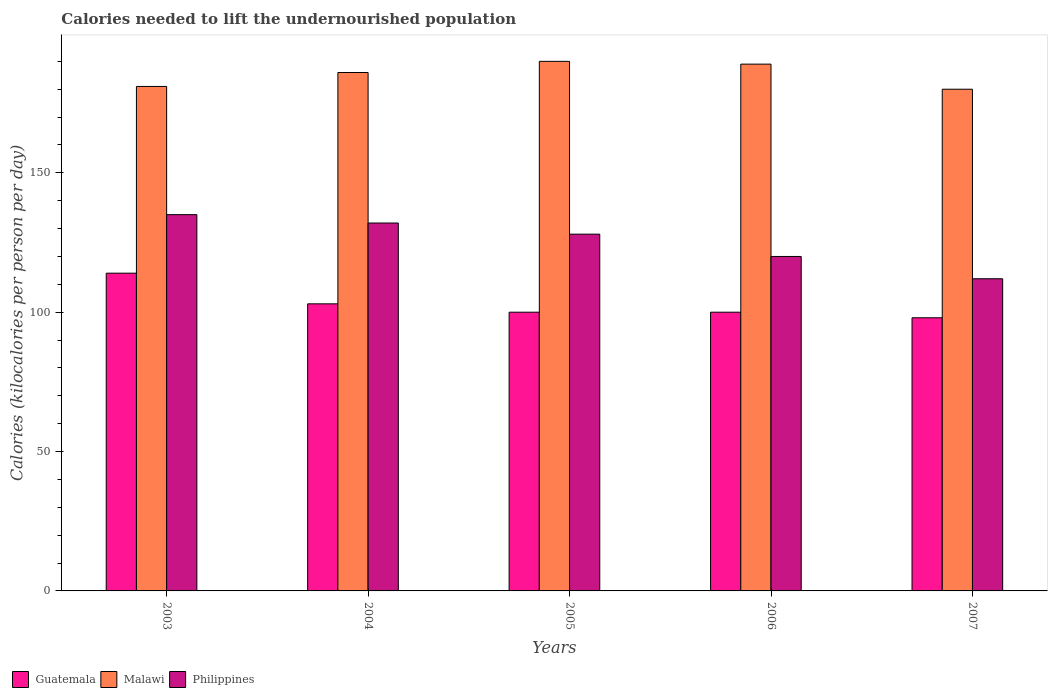How many bars are there on the 3rd tick from the left?
Offer a very short reply. 3. How many bars are there on the 1st tick from the right?
Offer a terse response. 3. What is the total calories needed to lift the undernourished population in Philippines in 2005?
Give a very brief answer. 128. Across all years, what is the maximum total calories needed to lift the undernourished population in Philippines?
Offer a very short reply. 135. Across all years, what is the minimum total calories needed to lift the undernourished population in Malawi?
Ensure brevity in your answer.  180. In which year was the total calories needed to lift the undernourished population in Malawi maximum?
Ensure brevity in your answer.  2005. What is the total total calories needed to lift the undernourished population in Malawi in the graph?
Ensure brevity in your answer.  926. What is the difference between the total calories needed to lift the undernourished population in Malawi in 2004 and that in 2005?
Your answer should be compact. -4. What is the difference between the total calories needed to lift the undernourished population in Malawi in 2003 and the total calories needed to lift the undernourished population in Philippines in 2006?
Keep it short and to the point. 61. What is the average total calories needed to lift the undernourished population in Guatemala per year?
Give a very brief answer. 103. In the year 2007, what is the difference between the total calories needed to lift the undernourished population in Malawi and total calories needed to lift the undernourished population in Guatemala?
Ensure brevity in your answer.  82. In how many years, is the total calories needed to lift the undernourished population in Guatemala greater than 120 kilocalories?
Offer a very short reply. 0. What is the ratio of the total calories needed to lift the undernourished population in Guatemala in 2003 to that in 2004?
Make the answer very short. 1.11. Is the total calories needed to lift the undernourished population in Guatemala in 2004 less than that in 2007?
Provide a succinct answer. No. What is the difference between the highest and the lowest total calories needed to lift the undernourished population in Guatemala?
Your answer should be very brief. 16. In how many years, is the total calories needed to lift the undernourished population in Malawi greater than the average total calories needed to lift the undernourished population in Malawi taken over all years?
Keep it short and to the point. 3. What does the 2nd bar from the left in 2005 represents?
Ensure brevity in your answer.  Malawi. What does the 2nd bar from the right in 2005 represents?
Provide a short and direct response. Malawi. Is it the case that in every year, the sum of the total calories needed to lift the undernourished population in Guatemala and total calories needed to lift the undernourished population in Philippines is greater than the total calories needed to lift the undernourished population in Malawi?
Provide a succinct answer. Yes. Are all the bars in the graph horizontal?
Offer a very short reply. No. How many years are there in the graph?
Your response must be concise. 5. What is the difference between two consecutive major ticks on the Y-axis?
Your answer should be very brief. 50. Does the graph contain any zero values?
Keep it short and to the point. No. Where does the legend appear in the graph?
Give a very brief answer. Bottom left. How are the legend labels stacked?
Your answer should be very brief. Horizontal. What is the title of the graph?
Offer a very short reply. Calories needed to lift the undernourished population. What is the label or title of the Y-axis?
Your answer should be very brief. Calories (kilocalories per person per day). What is the Calories (kilocalories per person per day) in Guatemala in 2003?
Your answer should be compact. 114. What is the Calories (kilocalories per person per day) of Malawi in 2003?
Your response must be concise. 181. What is the Calories (kilocalories per person per day) of Philippines in 2003?
Make the answer very short. 135. What is the Calories (kilocalories per person per day) in Guatemala in 2004?
Offer a terse response. 103. What is the Calories (kilocalories per person per day) of Malawi in 2004?
Offer a terse response. 186. What is the Calories (kilocalories per person per day) of Philippines in 2004?
Offer a terse response. 132. What is the Calories (kilocalories per person per day) of Malawi in 2005?
Offer a terse response. 190. What is the Calories (kilocalories per person per day) of Philippines in 2005?
Ensure brevity in your answer.  128. What is the Calories (kilocalories per person per day) in Malawi in 2006?
Your response must be concise. 189. What is the Calories (kilocalories per person per day) of Philippines in 2006?
Your response must be concise. 120. What is the Calories (kilocalories per person per day) of Malawi in 2007?
Keep it short and to the point. 180. What is the Calories (kilocalories per person per day) of Philippines in 2007?
Your answer should be very brief. 112. Across all years, what is the maximum Calories (kilocalories per person per day) in Guatemala?
Offer a terse response. 114. Across all years, what is the maximum Calories (kilocalories per person per day) in Malawi?
Offer a very short reply. 190. Across all years, what is the maximum Calories (kilocalories per person per day) of Philippines?
Provide a succinct answer. 135. Across all years, what is the minimum Calories (kilocalories per person per day) in Guatemala?
Your response must be concise. 98. Across all years, what is the minimum Calories (kilocalories per person per day) of Malawi?
Your answer should be compact. 180. Across all years, what is the minimum Calories (kilocalories per person per day) in Philippines?
Provide a succinct answer. 112. What is the total Calories (kilocalories per person per day) in Guatemala in the graph?
Provide a short and direct response. 515. What is the total Calories (kilocalories per person per day) of Malawi in the graph?
Your response must be concise. 926. What is the total Calories (kilocalories per person per day) of Philippines in the graph?
Your response must be concise. 627. What is the difference between the Calories (kilocalories per person per day) of Guatemala in 2003 and that in 2004?
Offer a very short reply. 11. What is the difference between the Calories (kilocalories per person per day) of Guatemala in 2003 and that in 2005?
Make the answer very short. 14. What is the difference between the Calories (kilocalories per person per day) of Malawi in 2003 and that in 2006?
Give a very brief answer. -8. What is the difference between the Calories (kilocalories per person per day) in Philippines in 2003 and that in 2006?
Your answer should be compact. 15. What is the difference between the Calories (kilocalories per person per day) in Philippines in 2003 and that in 2007?
Your answer should be compact. 23. What is the difference between the Calories (kilocalories per person per day) of Guatemala in 2004 and that in 2005?
Offer a terse response. 3. What is the difference between the Calories (kilocalories per person per day) in Malawi in 2004 and that in 2005?
Your answer should be very brief. -4. What is the difference between the Calories (kilocalories per person per day) of Guatemala in 2004 and that in 2006?
Give a very brief answer. 3. What is the difference between the Calories (kilocalories per person per day) of Malawi in 2004 and that in 2006?
Offer a very short reply. -3. What is the difference between the Calories (kilocalories per person per day) in Philippines in 2004 and that in 2006?
Ensure brevity in your answer.  12. What is the difference between the Calories (kilocalories per person per day) in Guatemala in 2004 and that in 2007?
Make the answer very short. 5. What is the difference between the Calories (kilocalories per person per day) of Philippines in 2004 and that in 2007?
Give a very brief answer. 20. What is the difference between the Calories (kilocalories per person per day) of Philippines in 2005 and that in 2006?
Offer a terse response. 8. What is the difference between the Calories (kilocalories per person per day) of Guatemala in 2005 and that in 2007?
Your response must be concise. 2. What is the difference between the Calories (kilocalories per person per day) in Malawi in 2005 and that in 2007?
Your answer should be very brief. 10. What is the difference between the Calories (kilocalories per person per day) in Philippines in 2006 and that in 2007?
Ensure brevity in your answer.  8. What is the difference between the Calories (kilocalories per person per day) of Guatemala in 2003 and the Calories (kilocalories per person per day) of Malawi in 2004?
Give a very brief answer. -72. What is the difference between the Calories (kilocalories per person per day) in Guatemala in 2003 and the Calories (kilocalories per person per day) in Philippines in 2004?
Offer a very short reply. -18. What is the difference between the Calories (kilocalories per person per day) in Malawi in 2003 and the Calories (kilocalories per person per day) in Philippines in 2004?
Offer a terse response. 49. What is the difference between the Calories (kilocalories per person per day) of Guatemala in 2003 and the Calories (kilocalories per person per day) of Malawi in 2005?
Make the answer very short. -76. What is the difference between the Calories (kilocalories per person per day) in Guatemala in 2003 and the Calories (kilocalories per person per day) in Malawi in 2006?
Offer a very short reply. -75. What is the difference between the Calories (kilocalories per person per day) of Guatemala in 2003 and the Calories (kilocalories per person per day) of Philippines in 2006?
Offer a very short reply. -6. What is the difference between the Calories (kilocalories per person per day) in Guatemala in 2003 and the Calories (kilocalories per person per day) in Malawi in 2007?
Give a very brief answer. -66. What is the difference between the Calories (kilocalories per person per day) in Guatemala in 2003 and the Calories (kilocalories per person per day) in Philippines in 2007?
Offer a terse response. 2. What is the difference between the Calories (kilocalories per person per day) in Guatemala in 2004 and the Calories (kilocalories per person per day) in Malawi in 2005?
Ensure brevity in your answer.  -87. What is the difference between the Calories (kilocalories per person per day) of Guatemala in 2004 and the Calories (kilocalories per person per day) of Malawi in 2006?
Ensure brevity in your answer.  -86. What is the difference between the Calories (kilocalories per person per day) of Malawi in 2004 and the Calories (kilocalories per person per day) of Philippines in 2006?
Your response must be concise. 66. What is the difference between the Calories (kilocalories per person per day) in Guatemala in 2004 and the Calories (kilocalories per person per day) in Malawi in 2007?
Offer a terse response. -77. What is the difference between the Calories (kilocalories per person per day) in Guatemala in 2004 and the Calories (kilocalories per person per day) in Philippines in 2007?
Provide a succinct answer. -9. What is the difference between the Calories (kilocalories per person per day) of Guatemala in 2005 and the Calories (kilocalories per person per day) of Malawi in 2006?
Your answer should be very brief. -89. What is the difference between the Calories (kilocalories per person per day) of Guatemala in 2005 and the Calories (kilocalories per person per day) of Philippines in 2006?
Provide a succinct answer. -20. What is the difference between the Calories (kilocalories per person per day) of Malawi in 2005 and the Calories (kilocalories per person per day) of Philippines in 2006?
Keep it short and to the point. 70. What is the difference between the Calories (kilocalories per person per day) of Guatemala in 2005 and the Calories (kilocalories per person per day) of Malawi in 2007?
Offer a very short reply. -80. What is the difference between the Calories (kilocalories per person per day) in Guatemala in 2005 and the Calories (kilocalories per person per day) in Philippines in 2007?
Your response must be concise. -12. What is the difference between the Calories (kilocalories per person per day) of Guatemala in 2006 and the Calories (kilocalories per person per day) of Malawi in 2007?
Your answer should be very brief. -80. What is the average Calories (kilocalories per person per day) in Guatemala per year?
Provide a short and direct response. 103. What is the average Calories (kilocalories per person per day) in Malawi per year?
Keep it short and to the point. 185.2. What is the average Calories (kilocalories per person per day) of Philippines per year?
Provide a succinct answer. 125.4. In the year 2003, what is the difference between the Calories (kilocalories per person per day) in Guatemala and Calories (kilocalories per person per day) in Malawi?
Offer a very short reply. -67. In the year 2004, what is the difference between the Calories (kilocalories per person per day) of Guatemala and Calories (kilocalories per person per day) of Malawi?
Provide a short and direct response. -83. In the year 2004, what is the difference between the Calories (kilocalories per person per day) in Guatemala and Calories (kilocalories per person per day) in Philippines?
Your answer should be compact. -29. In the year 2004, what is the difference between the Calories (kilocalories per person per day) in Malawi and Calories (kilocalories per person per day) in Philippines?
Offer a terse response. 54. In the year 2005, what is the difference between the Calories (kilocalories per person per day) of Guatemala and Calories (kilocalories per person per day) of Malawi?
Make the answer very short. -90. In the year 2006, what is the difference between the Calories (kilocalories per person per day) in Guatemala and Calories (kilocalories per person per day) in Malawi?
Give a very brief answer. -89. In the year 2007, what is the difference between the Calories (kilocalories per person per day) of Guatemala and Calories (kilocalories per person per day) of Malawi?
Offer a terse response. -82. In the year 2007, what is the difference between the Calories (kilocalories per person per day) in Guatemala and Calories (kilocalories per person per day) in Philippines?
Keep it short and to the point. -14. In the year 2007, what is the difference between the Calories (kilocalories per person per day) of Malawi and Calories (kilocalories per person per day) of Philippines?
Your answer should be compact. 68. What is the ratio of the Calories (kilocalories per person per day) in Guatemala in 2003 to that in 2004?
Offer a very short reply. 1.11. What is the ratio of the Calories (kilocalories per person per day) of Malawi in 2003 to that in 2004?
Provide a succinct answer. 0.97. What is the ratio of the Calories (kilocalories per person per day) in Philippines in 2003 to that in 2004?
Your answer should be very brief. 1.02. What is the ratio of the Calories (kilocalories per person per day) of Guatemala in 2003 to that in 2005?
Make the answer very short. 1.14. What is the ratio of the Calories (kilocalories per person per day) of Malawi in 2003 to that in 2005?
Give a very brief answer. 0.95. What is the ratio of the Calories (kilocalories per person per day) in Philippines in 2003 to that in 2005?
Your response must be concise. 1.05. What is the ratio of the Calories (kilocalories per person per day) of Guatemala in 2003 to that in 2006?
Ensure brevity in your answer.  1.14. What is the ratio of the Calories (kilocalories per person per day) in Malawi in 2003 to that in 2006?
Offer a terse response. 0.96. What is the ratio of the Calories (kilocalories per person per day) in Guatemala in 2003 to that in 2007?
Make the answer very short. 1.16. What is the ratio of the Calories (kilocalories per person per day) of Malawi in 2003 to that in 2007?
Your response must be concise. 1.01. What is the ratio of the Calories (kilocalories per person per day) in Philippines in 2003 to that in 2007?
Your response must be concise. 1.21. What is the ratio of the Calories (kilocalories per person per day) in Guatemala in 2004 to that in 2005?
Offer a terse response. 1.03. What is the ratio of the Calories (kilocalories per person per day) in Malawi in 2004 to that in 2005?
Your answer should be compact. 0.98. What is the ratio of the Calories (kilocalories per person per day) of Philippines in 2004 to that in 2005?
Make the answer very short. 1.03. What is the ratio of the Calories (kilocalories per person per day) in Guatemala in 2004 to that in 2006?
Your response must be concise. 1.03. What is the ratio of the Calories (kilocalories per person per day) of Malawi in 2004 to that in 2006?
Ensure brevity in your answer.  0.98. What is the ratio of the Calories (kilocalories per person per day) in Guatemala in 2004 to that in 2007?
Your response must be concise. 1.05. What is the ratio of the Calories (kilocalories per person per day) of Philippines in 2004 to that in 2007?
Keep it short and to the point. 1.18. What is the ratio of the Calories (kilocalories per person per day) in Guatemala in 2005 to that in 2006?
Provide a succinct answer. 1. What is the ratio of the Calories (kilocalories per person per day) of Philippines in 2005 to that in 2006?
Make the answer very short. 1.07. What is the ratio of the Calories (kilocalories per person per day) in Guatemala in 2005 to that in 2007?
Make the answer very short. 1.02. What is the ratio of the Calories (kilocalories per person per day) of Malawi in 2005 to that in 2007?
Provide a succinct answer. 1.06. What is the ratio of the Calories (kilocalories per person per day) of Philippines in 2005 to that in 2007?
Give a very brief answer. 1.14. What is the ratio of the Calories (kilocalories per person per day) in Guatemala in 2006 to that in 2007?
Provide a succinct answer. 1.02. What is the ratio of the Calories (kilocalories per person per day) of Malawi in 2006 to that in 2007?
Offer a very short reply. 1.05. What is the ratio of the Calories (kilocalories per person per day) in Philippines in 2006 to that in 2007?
Make the answer very short. 1.07. What is the difference between the highest and the second highest Calories (kilocalories per person per day) in Malawi?
Keep it short and to the point. 1. What is the difference between the highest and the second highest Calories (kilocalories per person per day) of Philippines?
Offer a terse response. 3. What is the difference between the highest and the lowest Calories (kilocalories per person per day) of Malawi?
Provide a short and direct response. 10. 